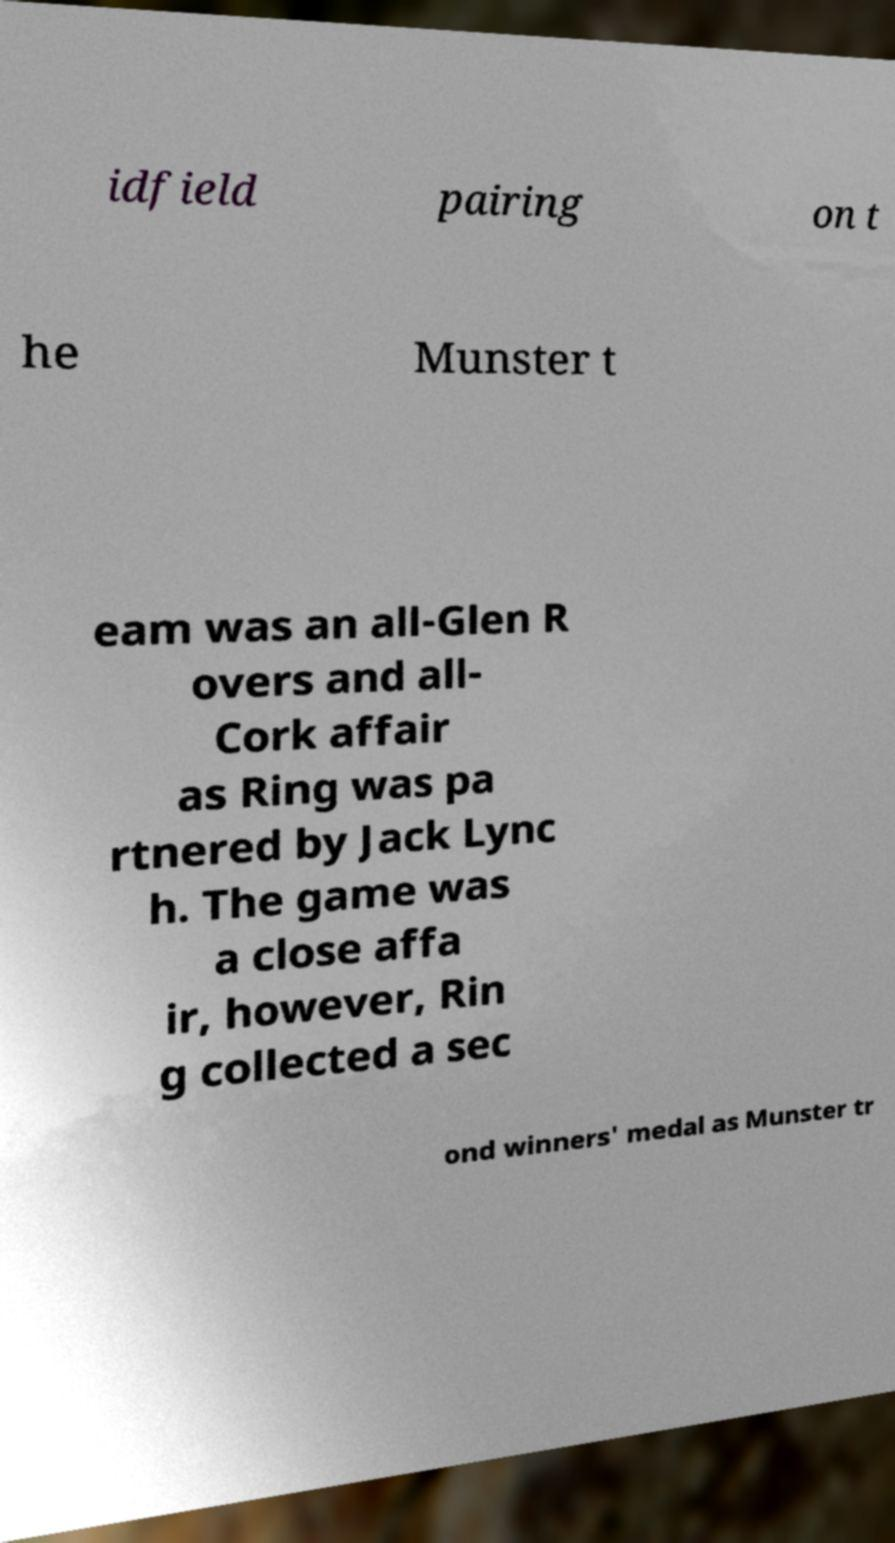Please identify and transcribe the text found in this image. idfield pairing on t he Munster t eam was an all-Glen R overs and all- Cork affair as Ring was pa rtnered by Jack Lync h. The game was a close affa ir, however, Rin g collected a sec ond winners' medal as Munster tr 